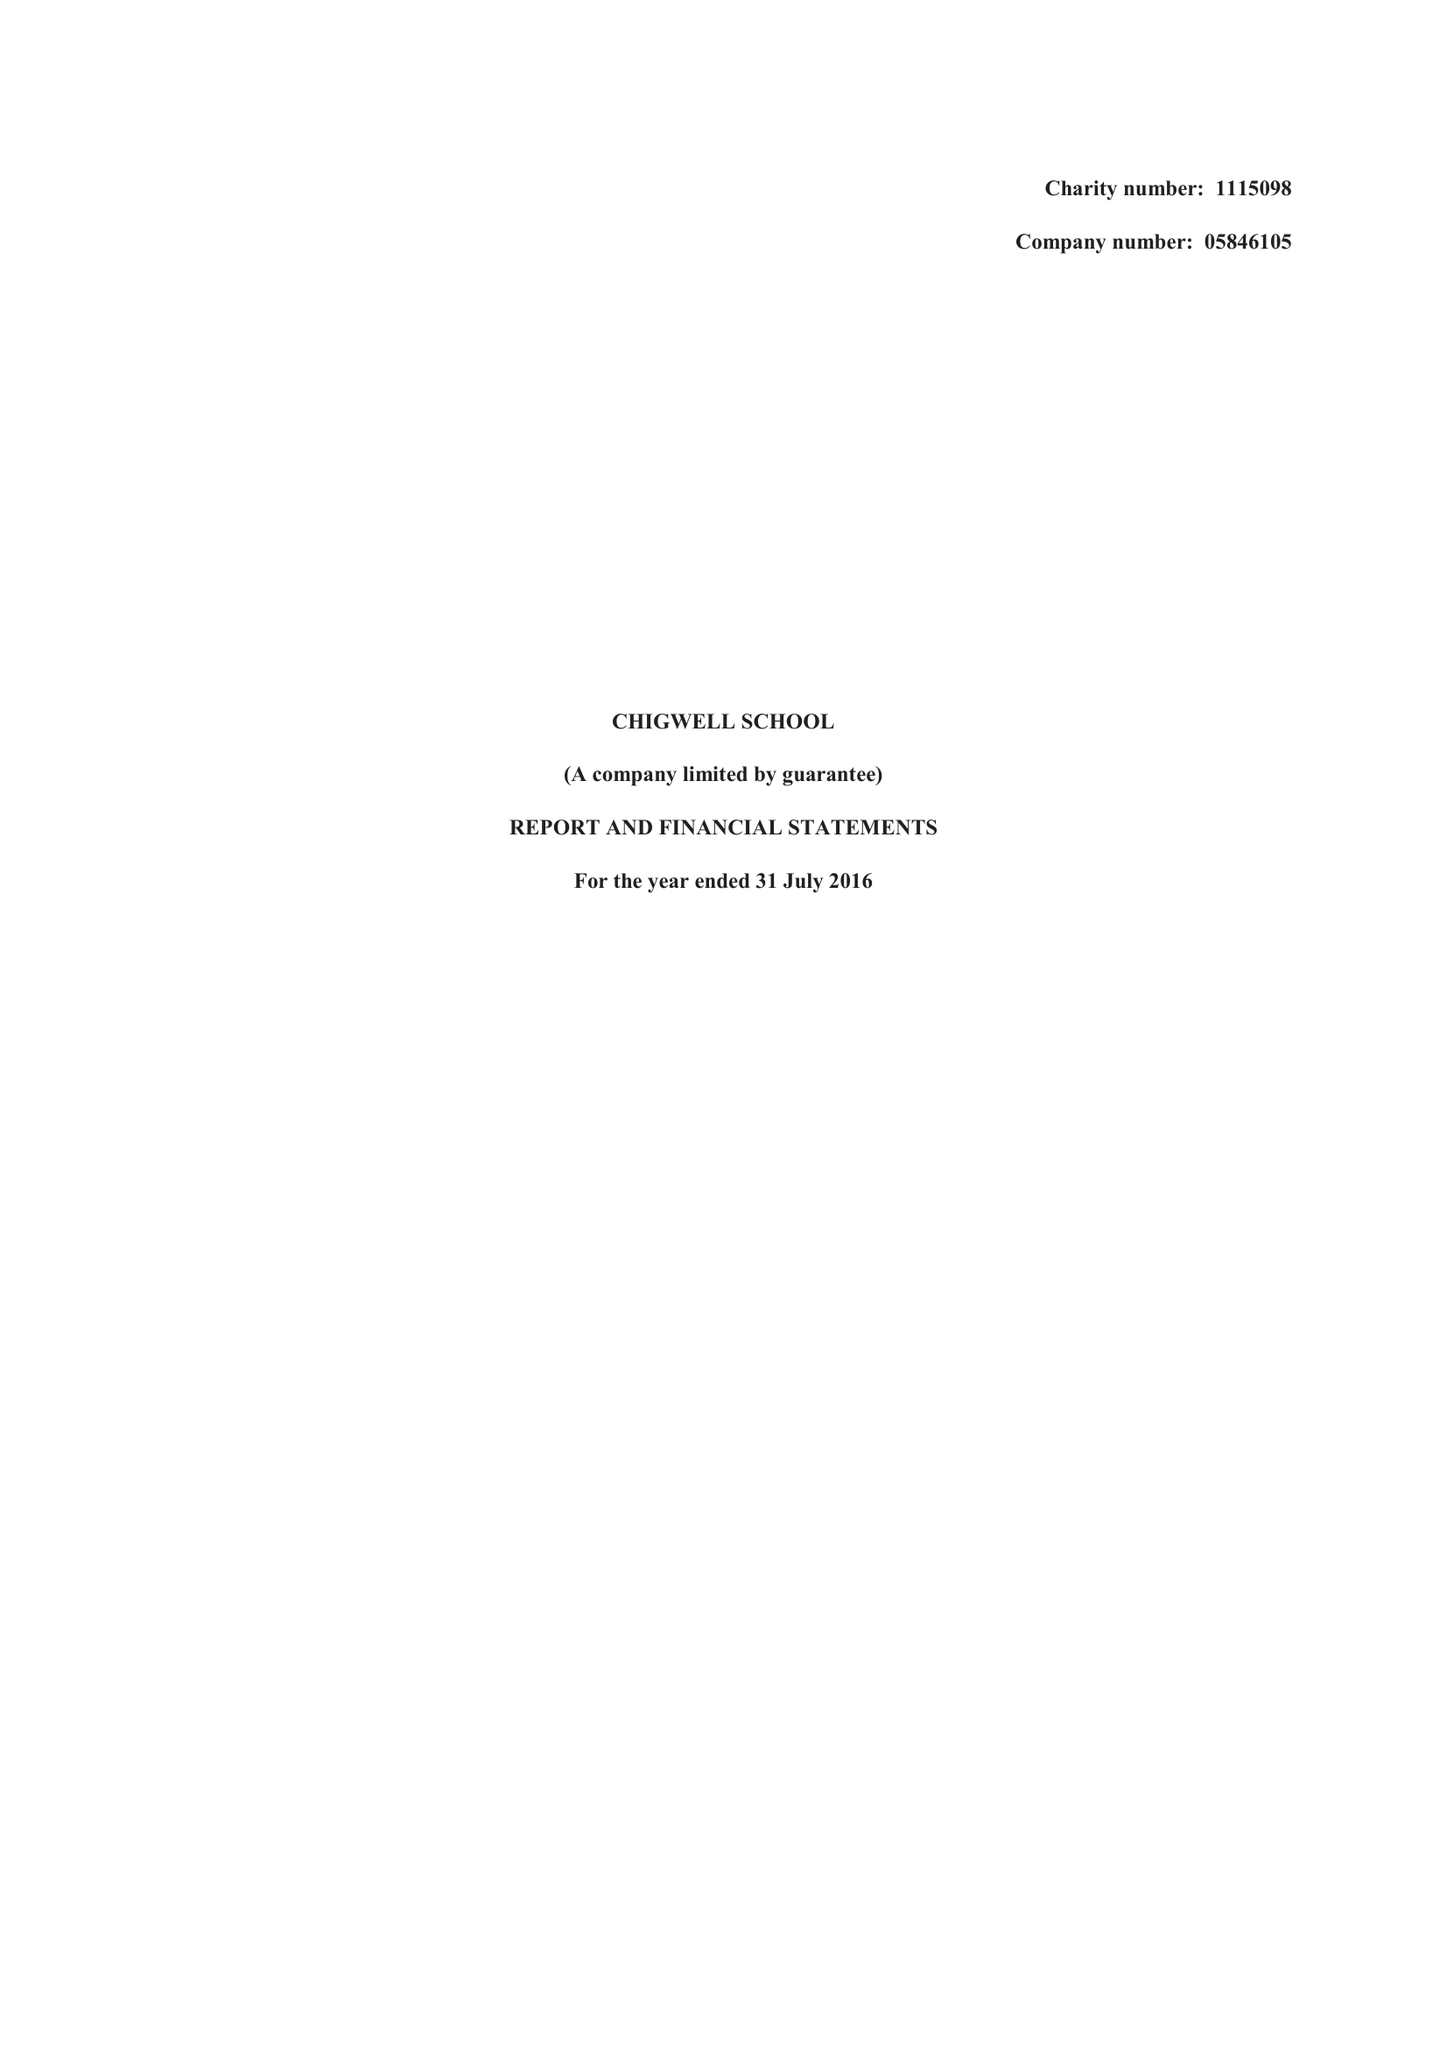What is the value for the income_annually_in_british_pounds?
Answer the question using a single word or phrase. 13584000.00 